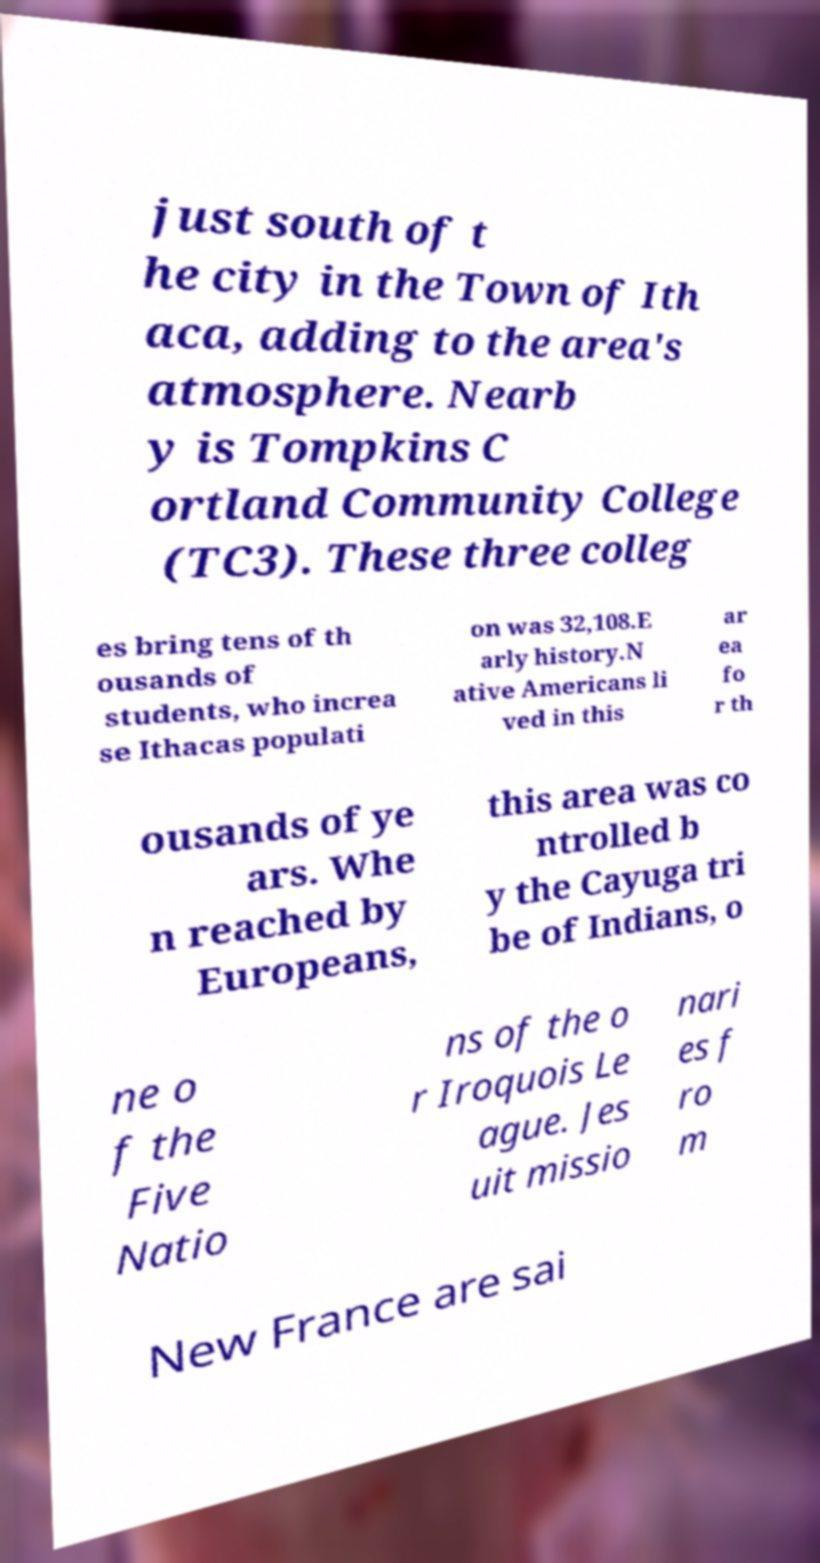Can you read and provide the text displayed in the image?This photo seems to have some interesting text. Can you extract and type it out for me? just south of t he city in the Town of Ith aca, adding to the area's atmosphere. Nearb y is Tompkins C ortland Community College (TC3). These three colleg es bring tens of th ousands of students, who increa se Ithacas populati on was 32,108.E arly history.N ative Americans li ved in this ar ea fo r th ousands of ye ars. Whe n reached by Europeans, this area was co ntrolled b y the Cayuga tri be of Indians, o ne o f the Five Natio ns of the o r Iroquois Le ague. Jes uit missio nari es f ro m New France are sai 